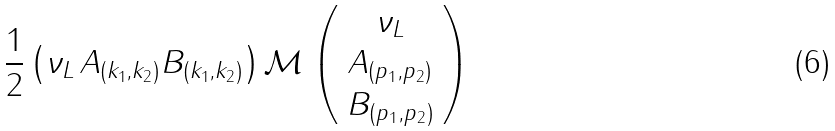<formula> <loc_0><loc_0><loc_500><loc_500>\frac { 1 } { 2 } \left ( \nu _ { L } \, A _ { ( k _ { 1 } , k _ { 2 } ) } B _ { ( k _ { 1 } , k _ { 2 } ) } \right ) \mathcal { M } \left ( \begin{array} { c } \nu _ { L } \\ A _ { ( p _ { 1 } , p _ { 2 } ) } \\ B _ { ( p _ { 1 } , p _ { 2 } ) } \end{array} \right )</formula> 